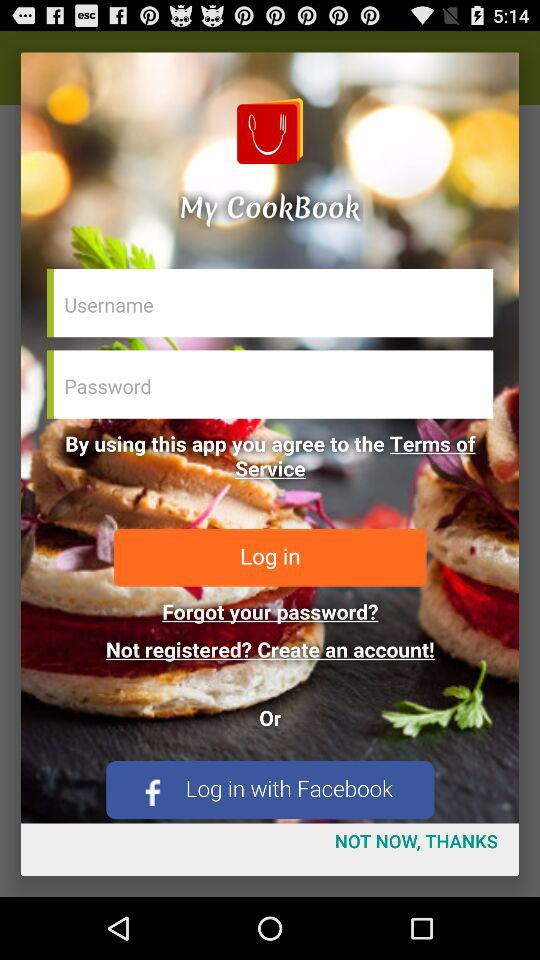What is the app name? The app name is "My CookBook". 